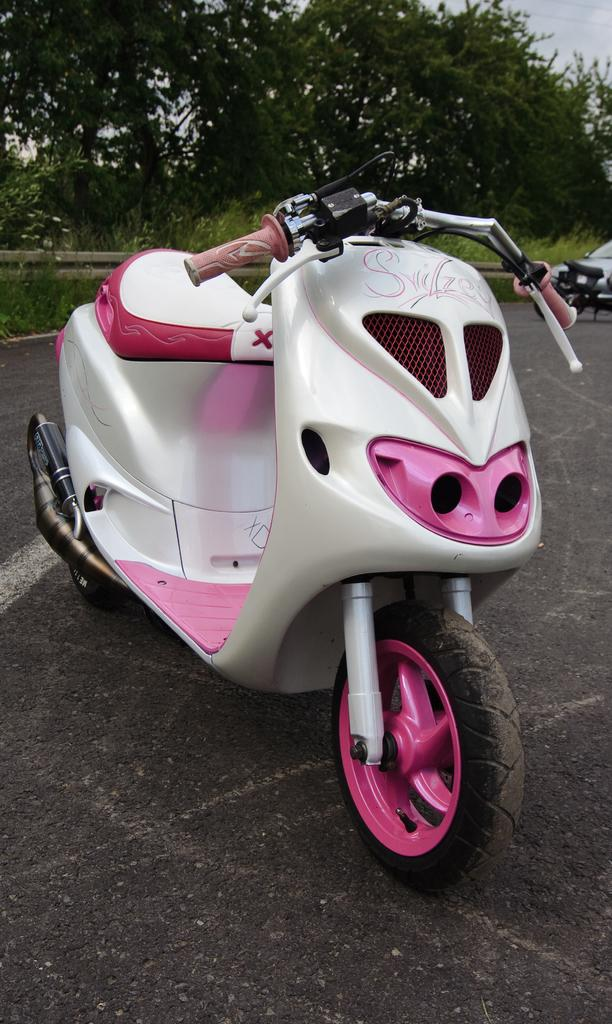What is the main subject in the middle of the image? There is a bike in the middle of the image. What can be seen in the background of the image? There are vehicles, trees, grass, a fence, and the sky visible in the background of the image. What type of surface is at the bottom of the image? There is a road at the bottom of the image. What type of coat is the zoo wearing in the image? There is no zoo present in the image, and therefore no coat can be attributed to it. 